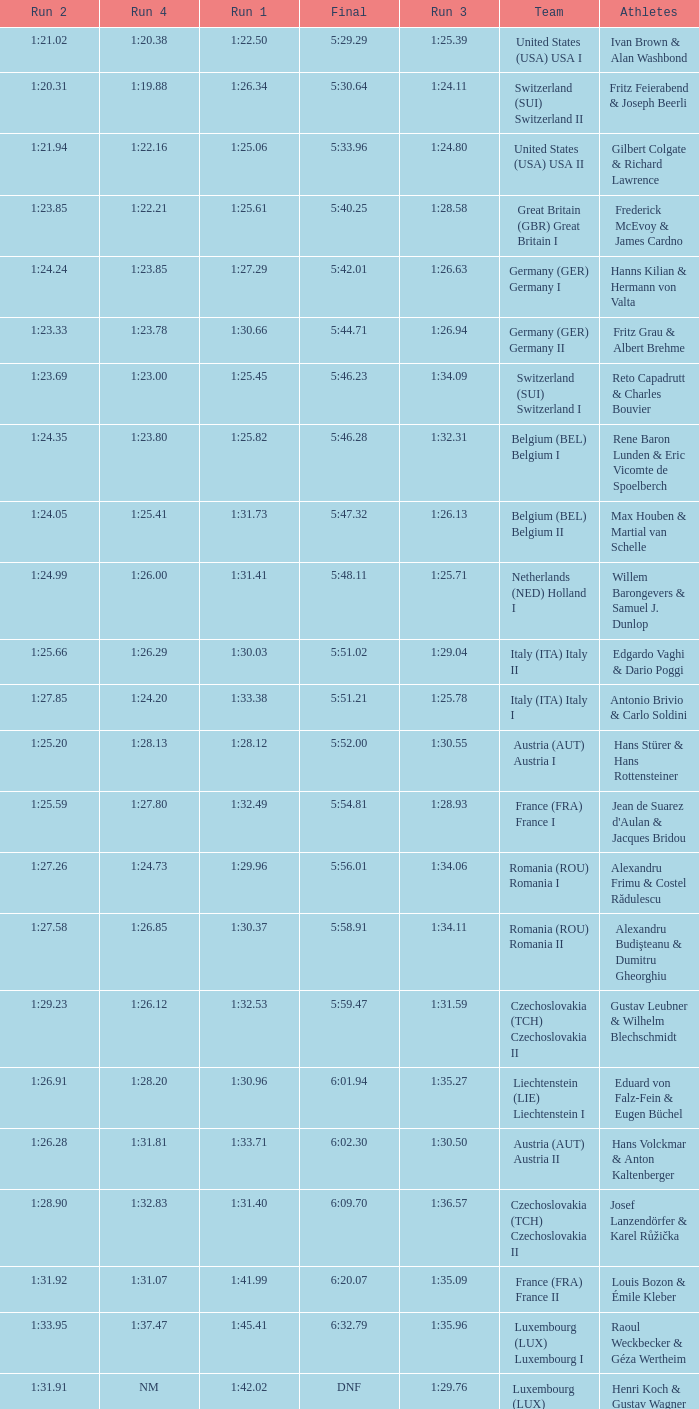Which Final has a Team of liechtenstein (lie) liechtenstein i? 6:01.94. 